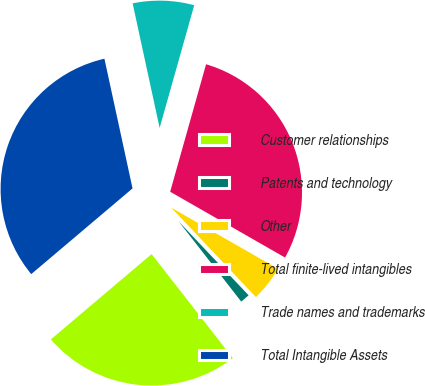Convert chart. <chart><loc_0><loc_0><loc_500><loc_500><pie_chart><fcel>Customer relationships<fcel>Patents and technology<fcel>Other<fcel>Total finite-lived intangibles<fcel>Trade names and trademarks<fcel>Total Intangible Assets<nl><fcel>24.37%<fcel>1.52%<fcel>4.65%<fcel>28.91%<fcel>7.77%<fcel>32.78%<nl></chart> 